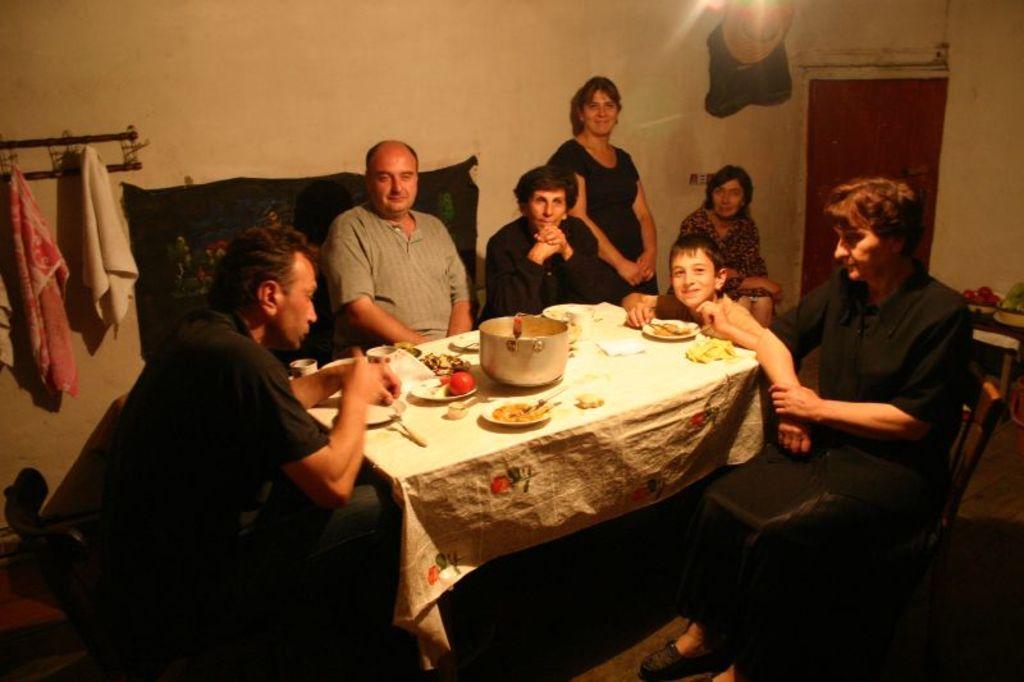Describe this image in one or two sentences. There are seven people sitting around the table where few food items are placed on the table. 